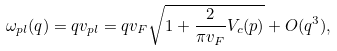Convert formula to latex. <formula><loc_0><loc_0><loc_500><loc_500>\omega _ { p l } ( q ) = q v _ { p l } = q v _ { F } \sqrt { 1 + \frac { 2 } { \pi v _ { F } } V _ { c } ( p ) } + O ( q ^ { 3 } ) ,</formula> 